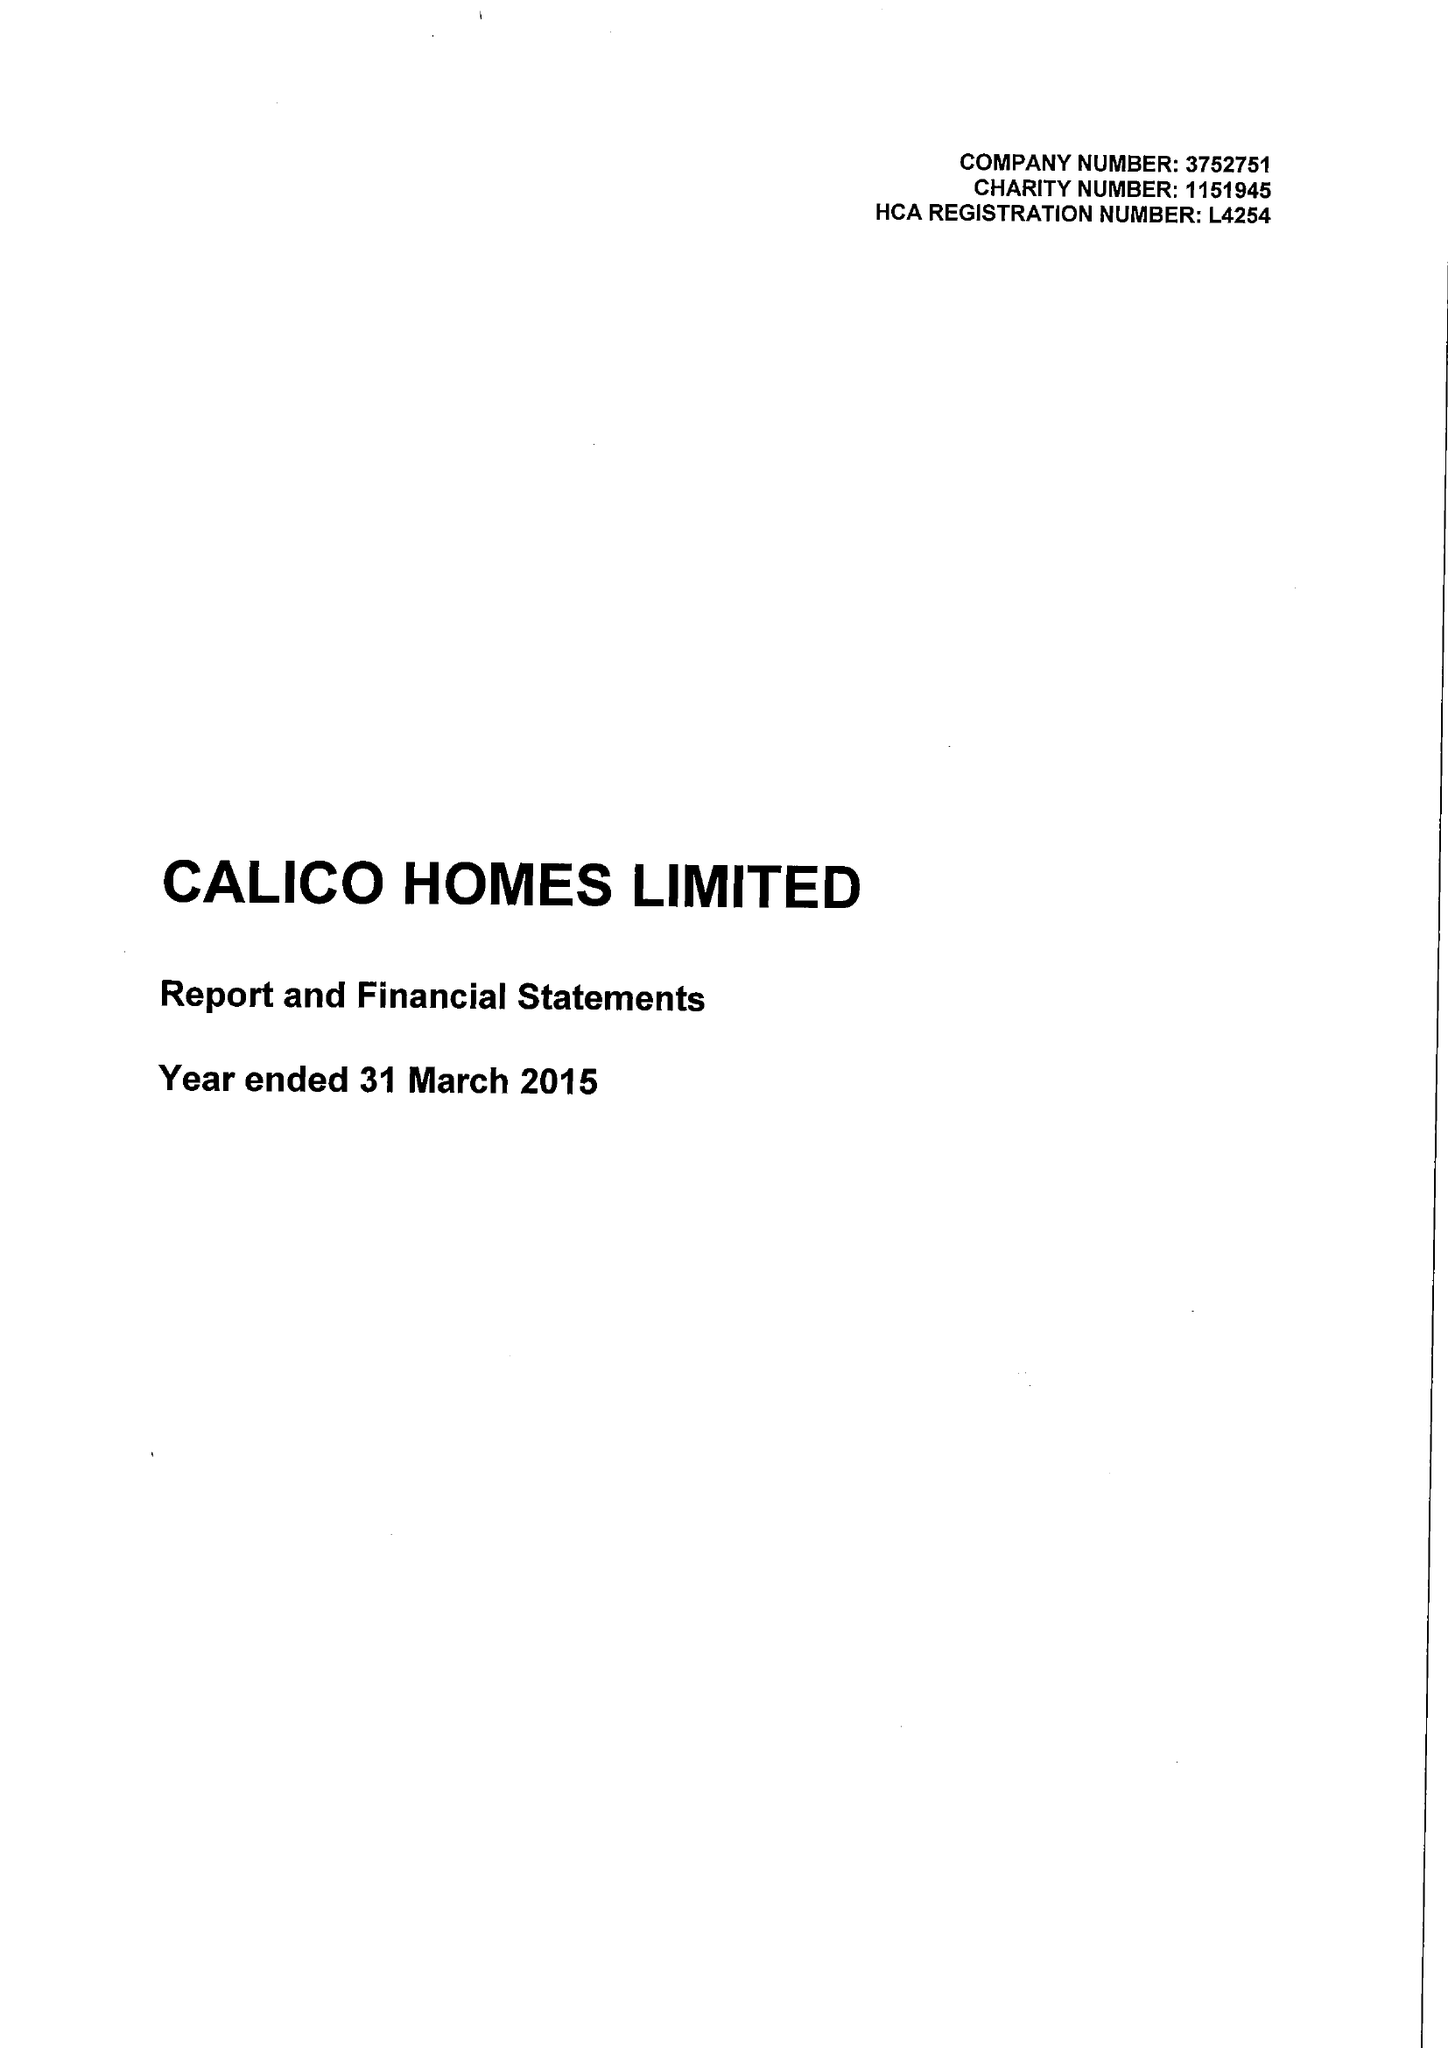What is the value for the address__street_line?
Answer the question using a single word or phrase. CROFT STREET 